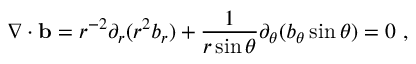Convert formula to latex. <formula><loc_0><loc_0><loc_500><loc_500>\nabla \cdot { b } = r ^ { - 2 } \partial _ { r } ( r ^ { 2 } b _ { r } ) + \frac { 1 } { r \sin \theta } \partial _ { \theta } ( b _ { \theta } \sin \theta ) = 0 \ ,</formula> 